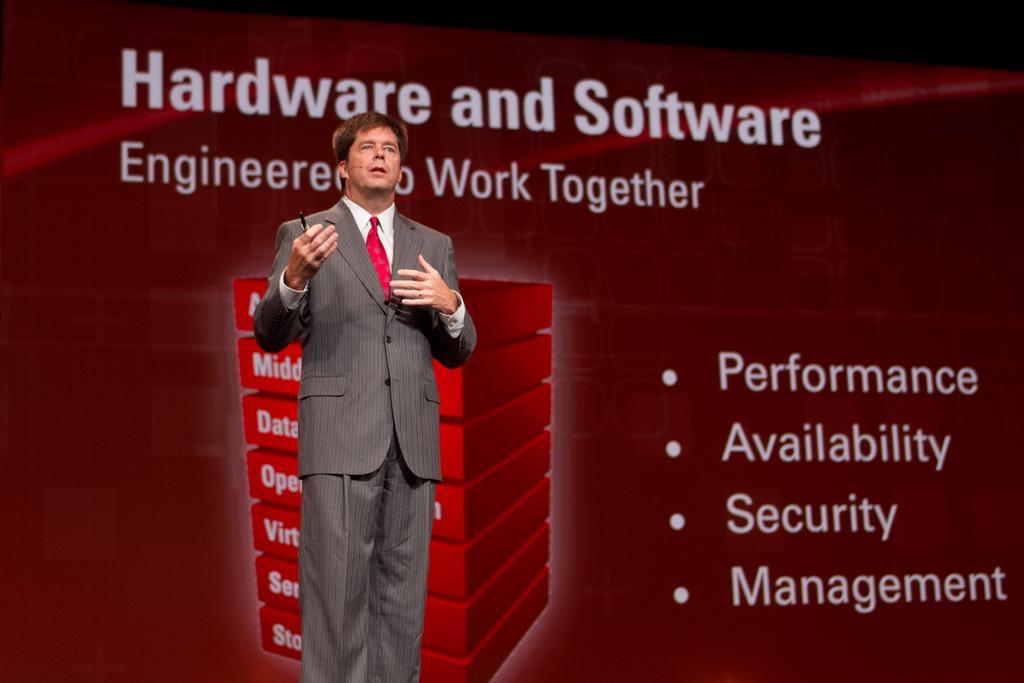Can you describe this image briefly? In this picture, we can see a person holding some object, we can see the background with some text, and images on it. 